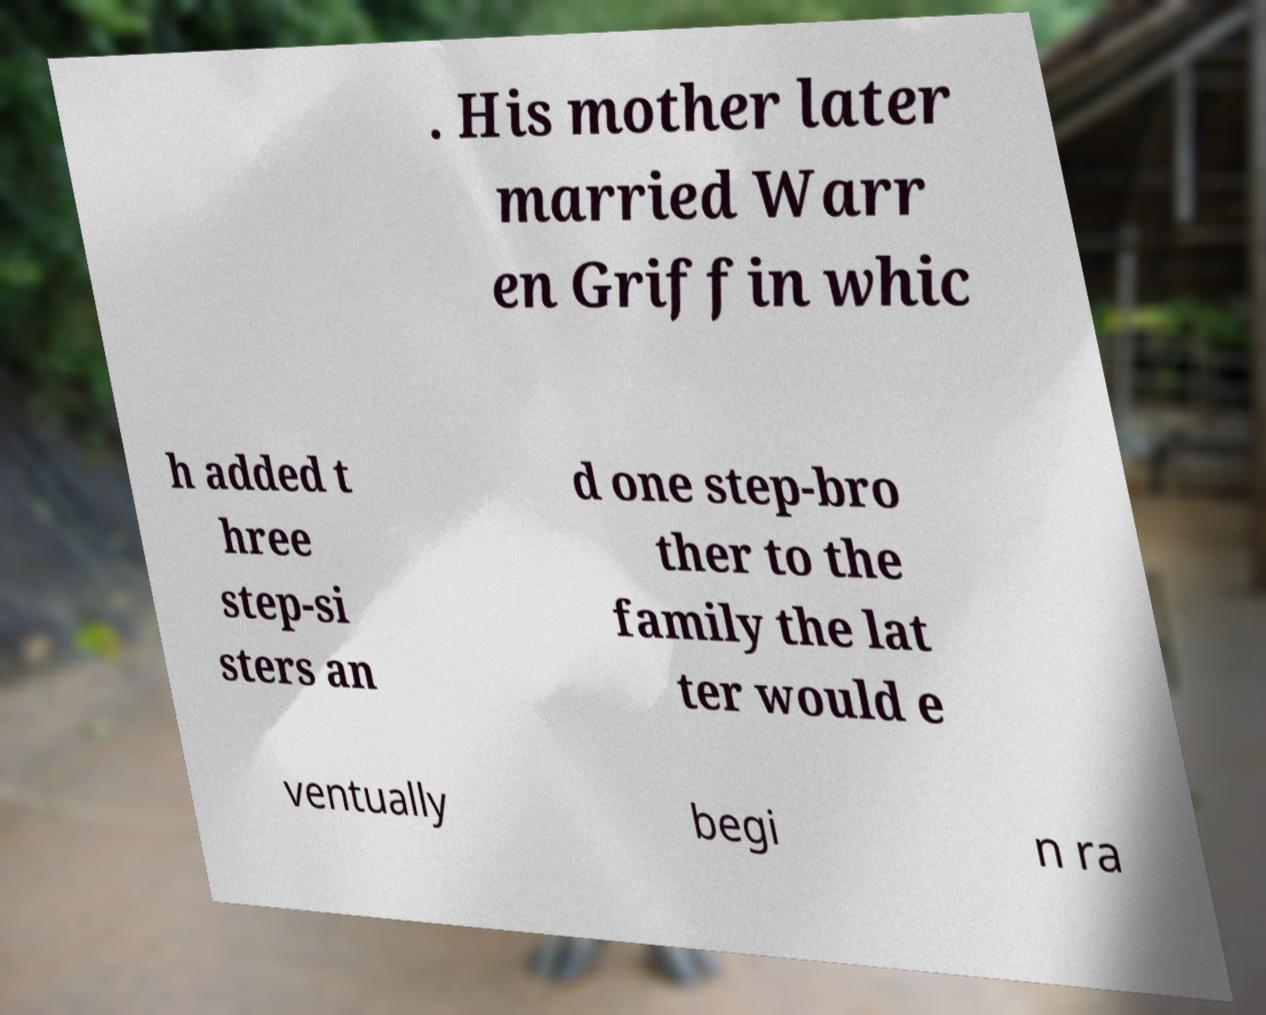Could you extract and type out the text from this image? . His mother later married Warr en Griffin whic h added t hree step-si sters an d one step-bro ther to the family the lat ter would e ventually begi n ra 